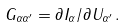<formula> <loc_0><loc_0><loc_500><loc_500>G _ { \alpha \alpha ^ { \prime } } = \partial I _ { \alpha } / \partial U _ { \alpha ^ { \prime } } \, .</formula> 